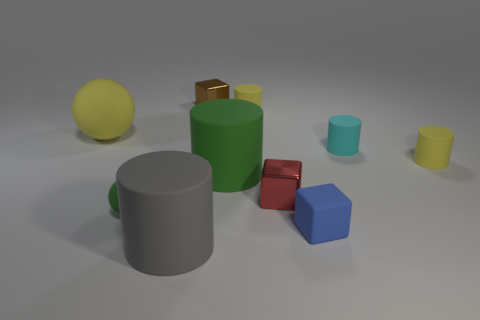Subtract all large matte cylinders. How many cylinders are left? 3 Subtract all cyan blocks. How many yellow cylinders are left? 2 Subtract all gray cylinders. How many cylinders are left? 4 Subtract 0 brown cylinders. How many objects are left? 10 Subtract all blocks. How many objects are left? 7 Subtract all green cylinders. Subtract all brown spheres. How many cylinders are left? 4 Subtract all small blue rubber spheres. Subtract all big matte cylinders. How many objects are left? 8 Add 3 small matte things. How many small matte things are left? 8 Add 2 brown metal things. How many brown metal things exist? 3 